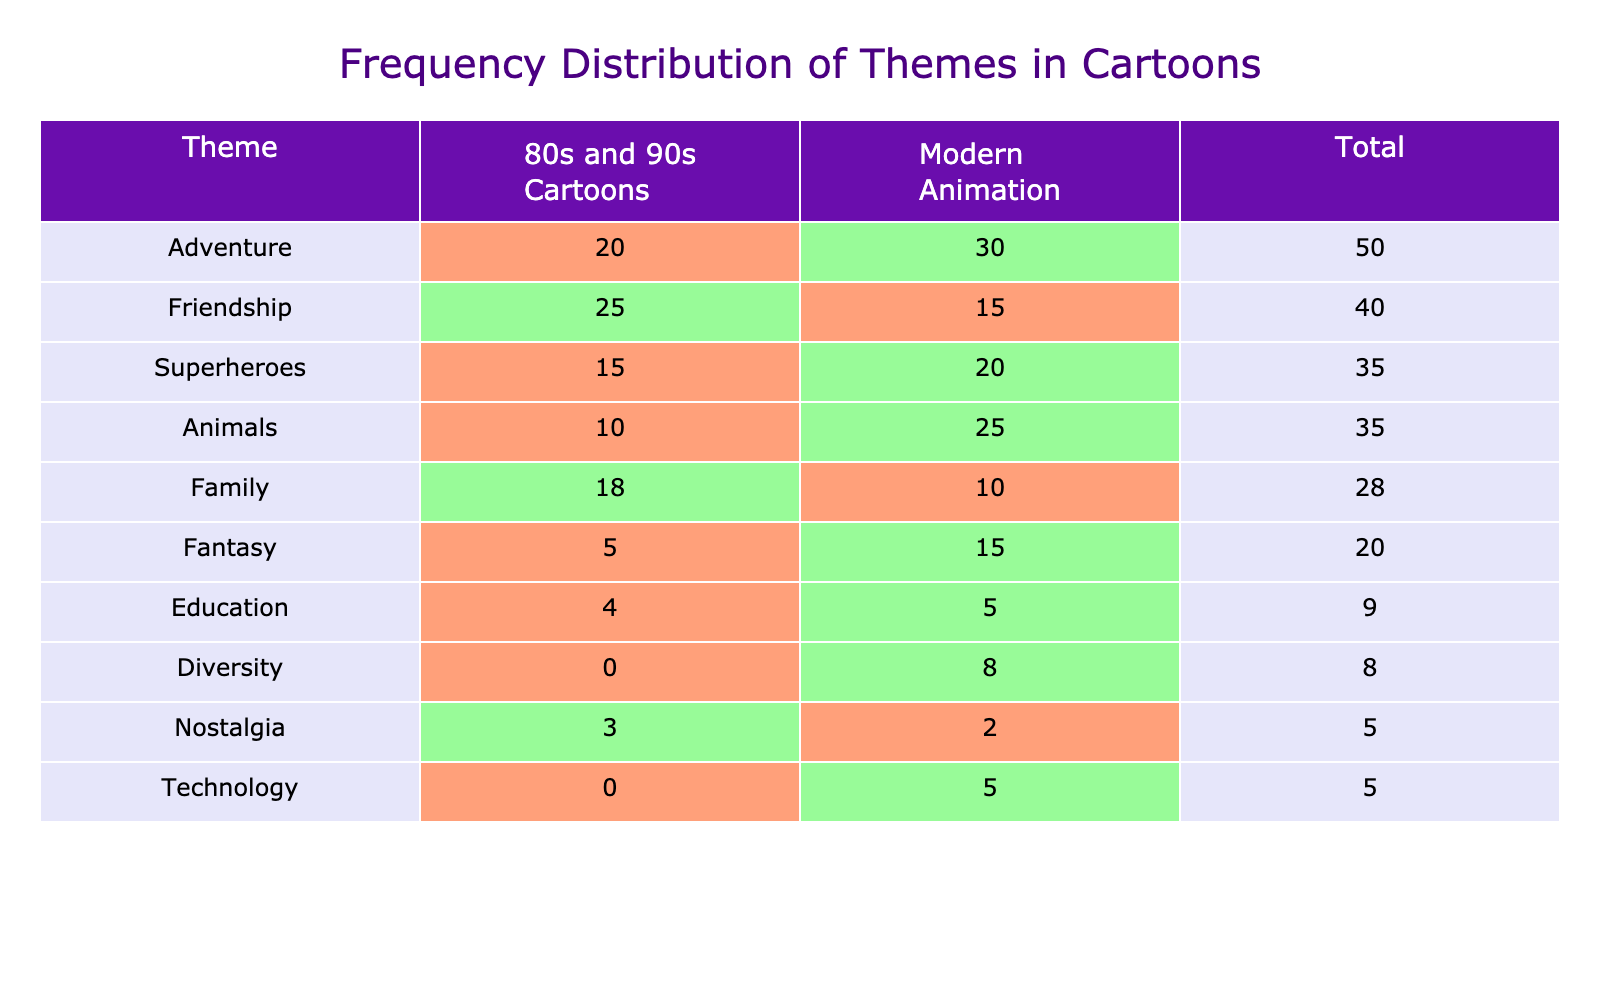What is the total number of themes presented in the table? The table lists individual themes under both categories, "80s and 90s Cartoons" and "Modern Animation." Counting the themes listed, there are 10 themes.
Answer: 10 Which theme has the highest frequency in "80s and 90s Cartoons"? Looking at the column for "80s and 90s Cartoons," the theme with the highest value is "Friendship," which has a frequency of 25.
Answer: Friendship What is the difference in frequency for the theme "Adventure" between the two categories? To find the difference, I subtract the frequency of "80s and 90s Cartoons" (20) from that of "Modern Animation" (30), giving a difference of 30 - 20 = 10.
Answer: 10 Is there a theme that had a frequency of 0 in "80s and 90s Cartoons"? Looking at the "80s and 90s Cartoons" column, the "Technology" and "Diversity" themes both show a frequency of 0, which confirms that there are themes with that frequency.
Answer: Yes Which theme shows the greatest increase in frequency from the 80s and 90s to modern animation? For each theme, compare the frequencies: "Adventure" (increase of 10), "Animals" (increase of 15), "Superheroes" (increase of 5), and "Technology" (from 0 to 5). The theme "Animals" has the greatest increase from 10 to 25, resulting in a difference of 15.
Answer: Animals What is the total frequency for "Modern Animation"? Adding the frequencies of all themes under "Modern Animation": 15 + 30 + 10 + 20 + 25 + 15 + 5 + 2 + 5 + 8 = 130. Therefore, the total frequency is 130.
Answer: 130 Which two themes have the same frequency in "Modern Animation"? Checking the frequencies in the "Modern Animation" column, "Fantasy" and "Education" both have a frequency of 5.
Answer: Fantasy and Education Overall, do modern animations have higher thematic frequencies compared to the 80s and 90s cartoons? By observing the totals for each column, "80s and 90s Cartoons" adds up to 100 and "Modern Animation" to 130. Thus, modern animations have a higher total.
Answer: Yes What is the average frequency of themes in the "80s and 90s Cartoons" category? To calculate the average, sum all the frequencies for "80s and 90s Cartoons" (25 + 20 + 18 + 15 + 10 + 5 + 4 + 3 + 0 + 0 = 100) and divide by the number of themes (10), giving an average of 100/10 = 10.
Answer: 10 